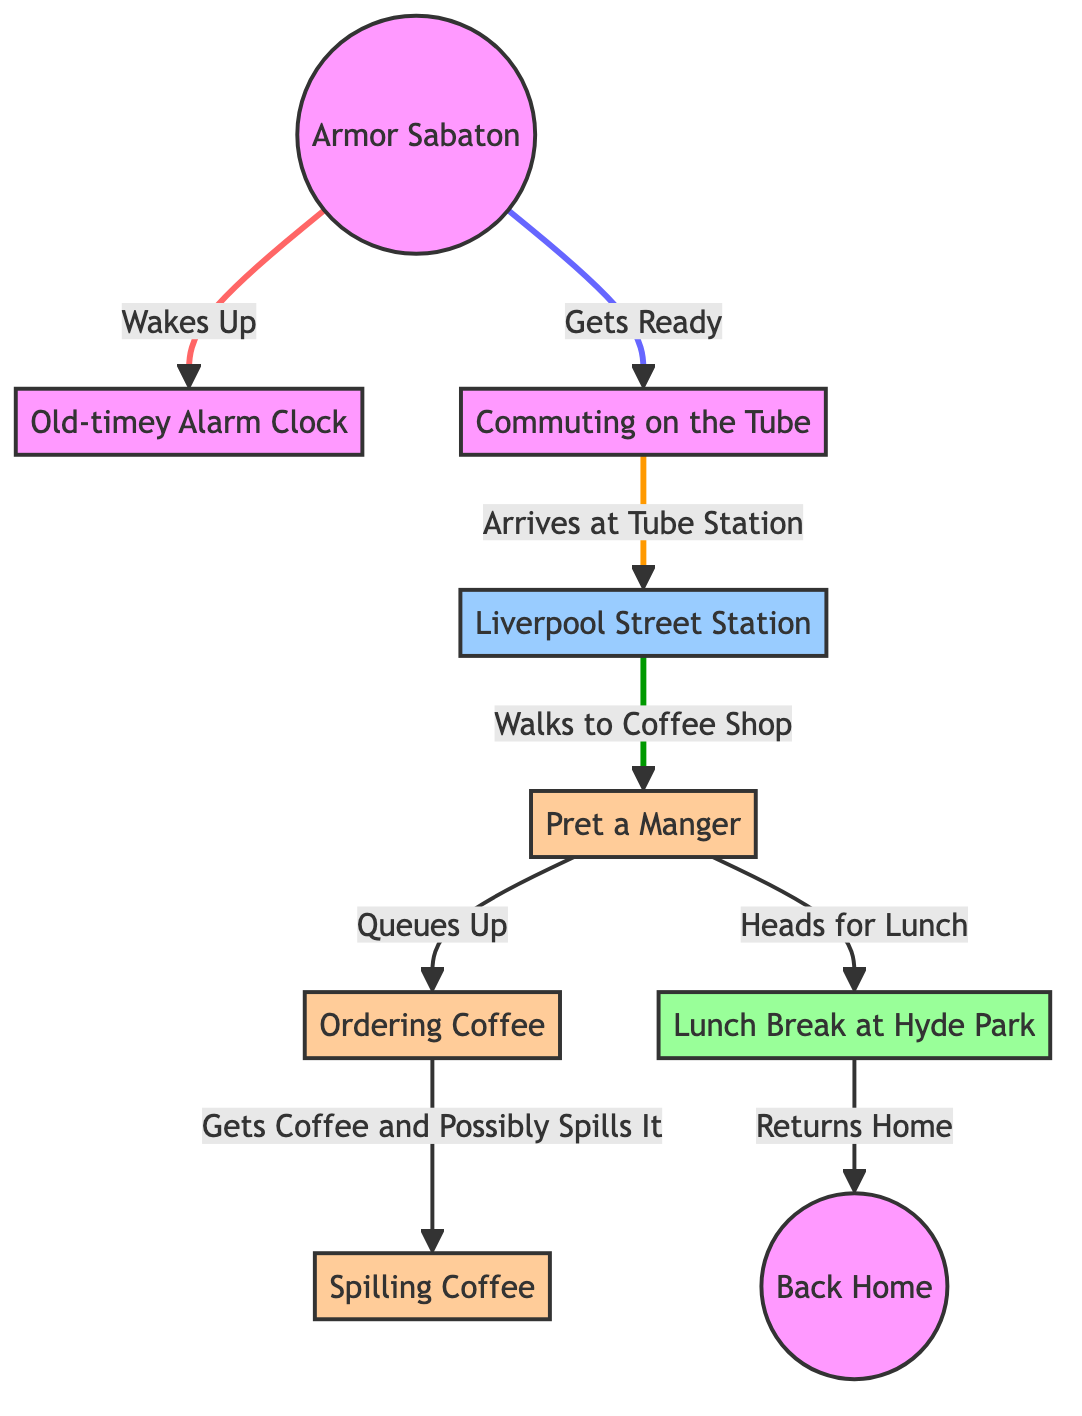What is the first activity the armor does in the morning? The diagram indicates that the first activity is waking up, which is derived from the arrow leading from "Armor Sabaton" to "Old-timey Alarm Clock" labeled "Wakes Up".
Answer: Wakes Up How many main locations does the armor visit in modern London? By tracing the diagram, we observe that the armor visits three main locations: the Tube Station, the Coffee Shop, and Hyde Park.
Answer: Three What does the armor do after commuting on the Tube? According to the diagram, after the armor arrives at the Tube Station, the next activity is walking to the Coffee Shop, as indicated by the flow from "Commuting on the Tube" to "Liverpool Street Station" followed by "Walks to Coffee Shop".
Answer: Walks to Coffee Shop Where does the armor have its lunch break? The diagram explicitly indicates the lunch break occurs at Hyde Park, as shown in the flow from the Coffee Shop to "Lunch Break at Hyde Park".
Answer: Hyde Park What happens after the armor orders coffee? After ordering coffee, the next event in the diagram is "Gets Coffee and Possibly Spills It", showing a direct progression after ordering.
Answer: Gets Coffee and Possibly Spills It What is the last location the armor returns to before ending the day's activities? The diagram indicates that after the lunch break, the armor returns home, as shown by the flow leading from "Lunch Break at Hyde Park" to "Back Home".
Answer: Back Home What is an activity that the armor humorously does at the coffee shop? The diagram humorously notes that the armor may spill coffee after ordering, which adds a surreal twist to the armor's day.
Answer: Spilling Coffee How does the armor commute to its destinations? The armor commutes via the Tube, as depicted by the node labeled "Commuting on the Tube", which is the method indicated for its travel through the diagram.
Answer: Tube 